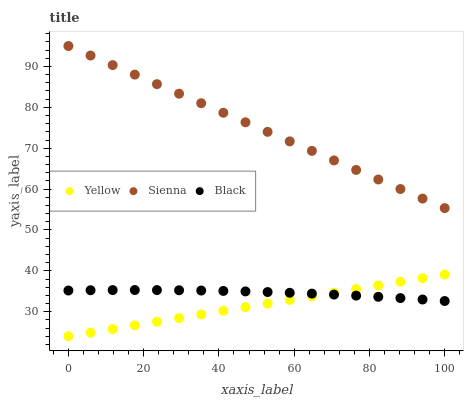Does Yellow have the minimum area under the curve?
Answer yes or no. Yes. Does Sienna have the maximum area under the curve?
Answer yes or no. Yes. Does Black have the minimum area under the curve?
Answer yes or no. No. Does Black have the maximum area under the curve?
Answer yes or no. No. Is Yellow the smoothest?
Answer yes or no. Yes. Is Black the roughest?
Answer yes or no. Yes. Is Black the smoothest?
Answer yes or no. No. Is Yellow the roughest?
Answer yes or no. No. Does Yellow have the lowest value?
Answer yes or no. Yes. Does Black have the lowest value?
Answer yes or no. No. Does Sienna have the highest value?
Answer yes or no. Yes. Does Yellow have the highest value?
Answer yes or no. No. Is Black less than Sienna?
Answer yes or no. Yes. Is Sienna greater than Yellow?
Answer yes or no. Yes. Does Yellow intersect Black?
Answer yes or no. Yes. Is Yellow less than Black?
Answer yes or no. No. Is Yellow greater than Black?
Answer yes or no. No. Does Black intersect Sienna?
Answer yes or no. No. 